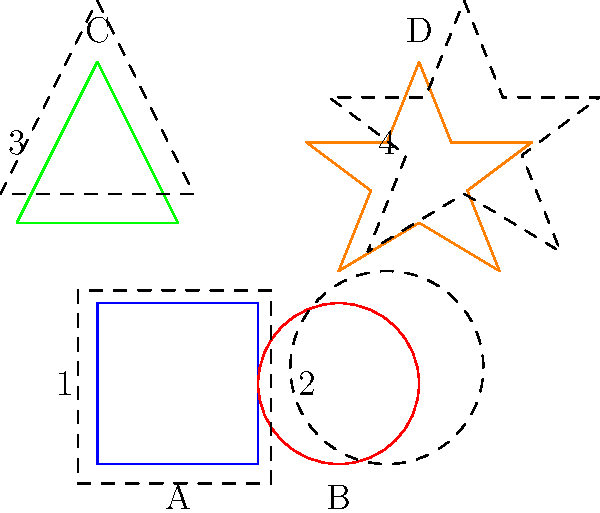Can you match each hospital sign shape to its dashed outline? Draw a line connecting each shape to its correct outline. Let's match each shape to its outline step-by-step:

1. Look at shape A (square):
   - Compare it to all dashed outlines
   - The square matches outline 1

2. Look at shape B (circle):
   - Compare it to all dashed outlines
   - The circle matches outline 2

3. Look at shape C (triangle):
   - Compare it to all dashed outlines
   - The triangle matches outline 3

4. Look at shape D (star):
   - Compare it to all dashed outlines
   - The star matches outline 4

Each shape has a slightly larger dashed outline that matches its unique form.
Answer: A-1, B-2, C-3, D-4 